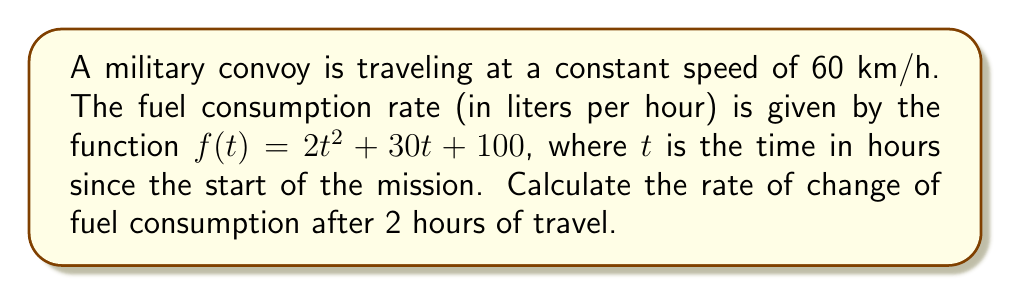Could you help me with this problem? To solve this problem, we need to find the derivative of the fuel consumption function and evaluate it at $t = 2$ hours. Let's break it down step-by-step:

1) The fuel consumption function is given as:
   $f(t) = 2t^2 + 30t + 100$

2) To find the rate of change of fuel consumption, we need to calculate $f'(t)$:
   $f'(t) = \frac{d}{dt}(2t^2 + 30t + 100)$

3) Using the power rule and constant rule of differentiation:
   $f'(t) = 2 \cdot 2t + 30 + 0$
   $f'(t) = 4t + 30$

4) Now, we need to evaluate $f'(t)$ at $t = 2$ hours:
   $f'(2) = 4(2) + 30$
   $f'(2) = 8 + 30 = 38$

5) Therefore, after 2 hours of travel, the rate of change of fuel consumption is 38 liters per hour per hour.

This means that at the 2-hour mark, the fuel consumption is increasing at a rate of 38 liters for each additional hour of travel.
Answer: 38 L/h² 